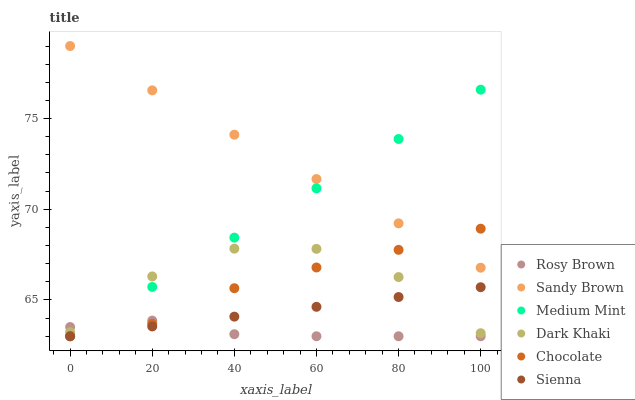Does Rosy Brown have the minimum area under the curve?
Answer yes or no. Yes. Does Sandy Brown have the maximum area under the curve?
Answer yes or no. Yes. Does Sienna have the minimum area under the curve?
Answer yes or no. No. Does Sienna have the maximum area under the curve?
Answer yes or no. No. Is Sandy Brown the smoothest?
Answer yes or no. Yes. Is Dark Khaki the roughest?
Answer yes or no. Yes. Is Sienna the smoothest?
Answer yes or no. No. Is Sienna the roughest?
Answer yes or no. No. Does Medium Mint have the lowest value?
Answer yes or no. Yes. Does Dark Khaki have the lowest value?
Answer yes or no. No. Does Sandy Brown have the highest value?
Answer yes or no. Yes. Does Sienna have the highest value?
Answer yes or no. No. Is Rosy Brown less than Sandy Brown?
Answer yes or no. Yes. Is Sandy Brown greater than Dark Khaki?
Answer yes or no. Yes. Does Rosy Brown intersect Medium Mint?
Answer yes or no. Yes. Is Rosy Brown less than Medium Mint?
Answer yes or no. No. Is Rosy Brown greater than Medium Mint?
Answer yes or no. No. Does Rosy Brown intersect Sandy Brown?
Answer yes or no. No. 